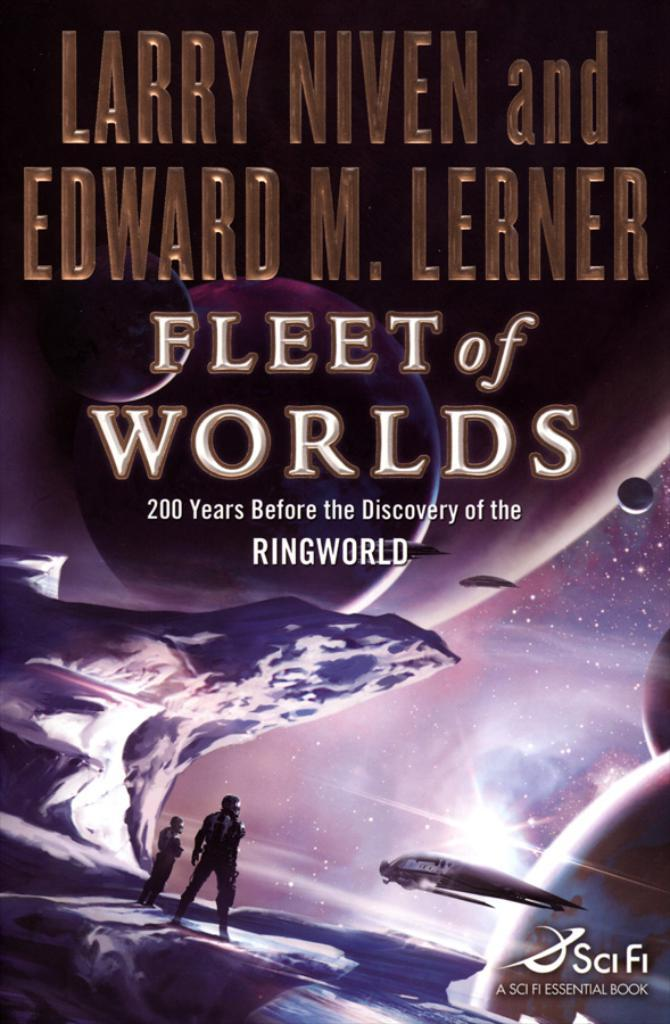<image>
Write a terse but informative summary of the picture. The front cover of a book called Fleet of Worlds 